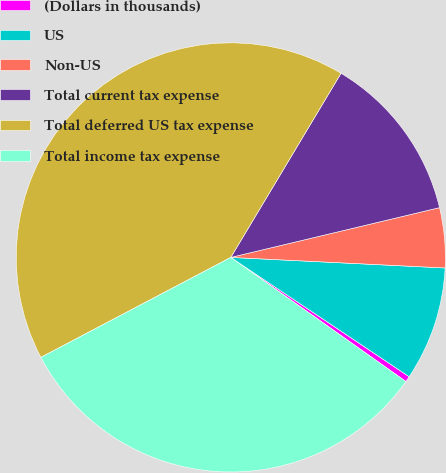Convert chart. <chart><loc_0><loc_0><loc_500><loc_500><pie_chart><fcel>(Dollars in thousands)<fcel>US<fcel>Non-US<fcel>Total current tax expense<fcel>Total deferred US tax expense<fcel>Total income tax expense<nl><fcel>0.43%<fcel>8.6%<fcel>4.51%<fcel>12.69%<fcel>41.3%<fcel>32.48%<nl></chart> 